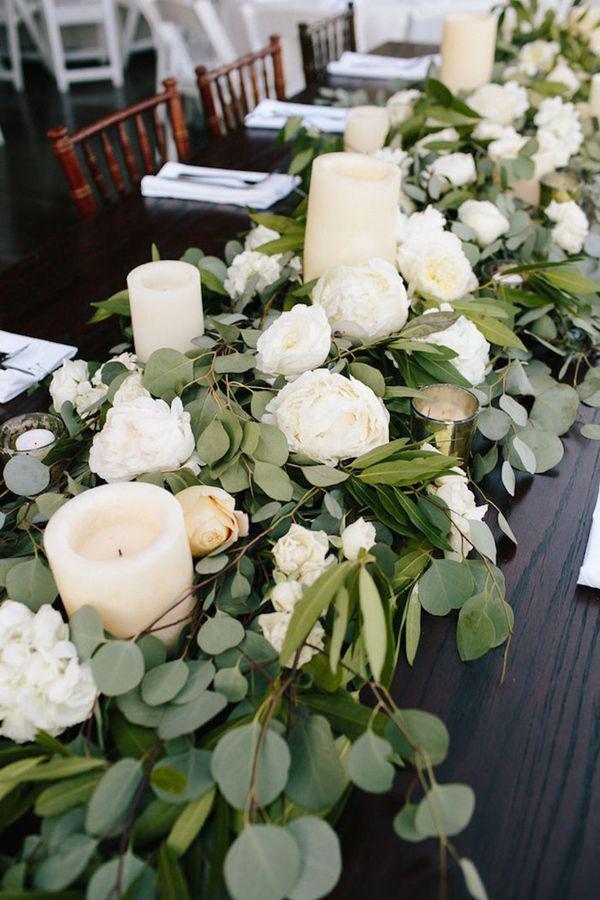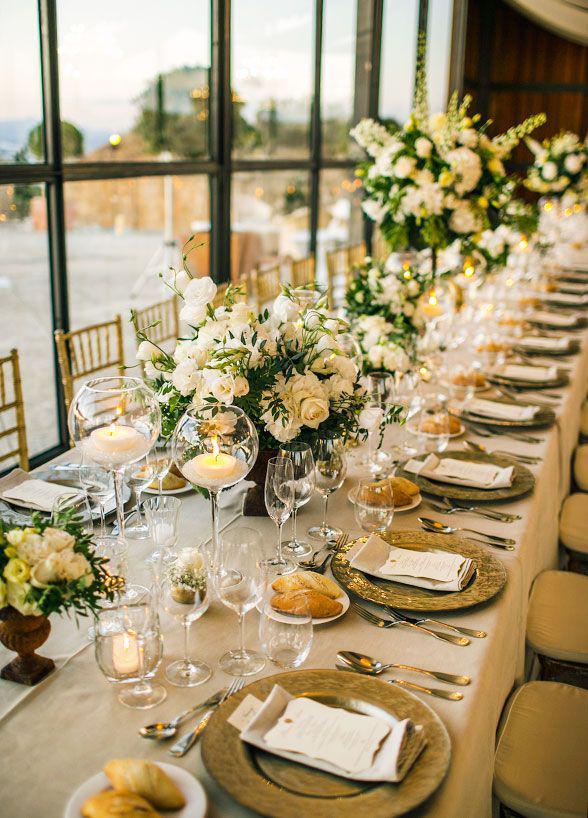The first image is the image on the left, the second image is the image on the right. Given the left and right images, does the statement "A plant with no flowers in a tall vase is used as a centerpiece on the table." hold true? Answer yes or no. No. The first image is the image on the left, the second image is the image on the right. For the images shown, is this caption "A single numbered label is on top of a decorated table." true? Answer yes or no. No. 